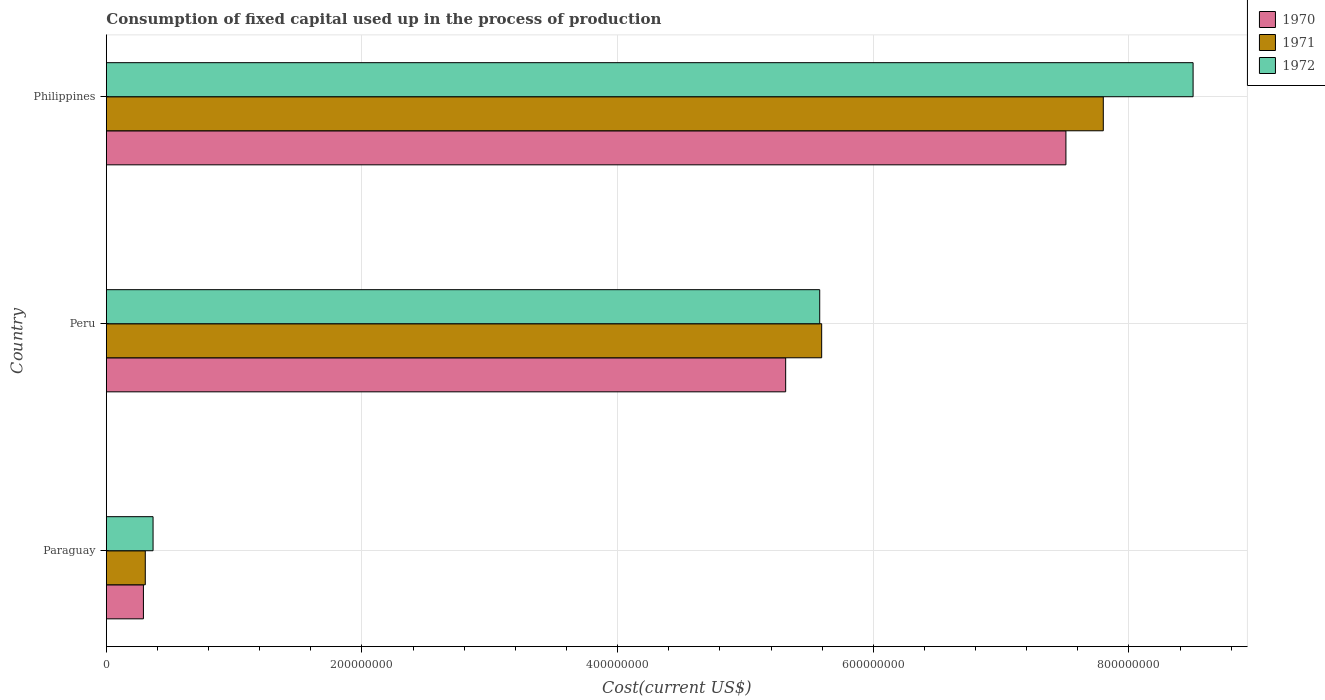How many different coloured bars are there?
Provide a succinct answer. 3. How many groups of bars are there?
Your answer should be very brief. 3. Are the number of bars on each tick of the Y-axis equal?
Your answer should be compact. Yes. How many bars are there on the 2nd tick from the top?
Give a very brief answer. 3. How many bars are there on the 3rd tick from the bottom?
Provide a short and direct response. 3. In how many cases, is the number of bars for a given country not equal to the number of legend labels?
Provide a succinct answer. 0. What is the amount consumed in the process of production in 1971 in Philippines?
Keep it short and to the point. 7.80e+08. Across all countries, what is the maximum amount consumed in the process of production in 1970?
Provide a short and direct response. 7.51e+08. Across all countries, what is the minimum amount consumed in the process of production in 1971?
Provide a succinct answer. 3.05e+07. In which country was the amount consumed in the process of production in 1970 maximum?
Give a very brief answer. Philippines. In which country was the amount consumed in the process of production in 1970 minimum?
Offer a very short reply. Paraguay. What is the total amount consumed in the process of production in 1970 in the graph?
Your answer should be compact. 1.31e+09. What is the difference between the amount consumed in the process of production in 1971 in Paraguay and that in Philippines?
Give a very brief answer. -7.50e+08. What is the difference between the amount consumed in the process of production in 1972 in Peru and the amount consumed in the process of production in 1970 in Paraguay?
Offer a terse response. 5.29e+08. What is the average amount consumed in the process of production in 1972 per country?
Your answer should be compact. 4.82e+08. What is the difference between the amount consumed in the process of production in 1972 and amount consumed in the process of production in 1971 in Peru?
Your response must be concise. -1.53e+06. In how many countries, is the amount consumed in the process of production in 1970 greater than 560000000 US$?
Your answer should be compact. 1. What is the ratio of the amount consumed in the process of production in 1971 in Paraguay to that in Peru?
Make the answer very short. 0.05. Is the amount consumed in the process of production in 1972 in Peru less than that in Philippines?
Your answer should be very brief. Yes. Is the difference between the amount consumed in the process of production in 1972 in Paraguay and Philippines greater than the difference between the amount consumed in the process of production in 1971 in Paraguay and Philippines?
Give a very brief answer. No. What is the difference between the highest and the second highest amount consumed in the process of production in 1970?
Keep it short and to the point. 2.19e+08. What is the difference between the highest and the lowest amount consumed in the process of production in 1972?
Offer a terse response. 8.14e+08. In how many countries, is the amount consumed in the process of production in 1971 greater than the average amount consumed in the process of production in 1971 taken over all countries?
Your answer should be very brief. 2. Is the sum of the amount consumed in the process of production in 1970 in Paraguay and Peru greater than the maximum amount consumed in the process of production in 1972 across all countries?
Give a very brief answer. No. Is it the case that in every country, the sum of the amount consumed in the process of production in 1971 and amount consumed in the process of production in 1972 is greater than the amount consumed in the process of production in 1970?
Offer a terse response. Yes. How many countries are there in the graph?
Offer a very short reply. 3. What is the difference between two consecutive major ticks on the X-axis?
Keep it short and to the point. 2.00e+08. Are the values on the major ticks of X-axis written in scientific E-notation?
Offer a very short reply. No. Does the graph contain any zero values?
Provide a short and direct response. No. What is the title of the graph?
Ensure brevity in your answer.  Consumption of fixed capital used up in the process of production. What is the label or title of the X-axis?
Provide a short and direct response. Cost(current US$). What is the label or title of the Y-axis?
Give a very brief answer. Country. What is the Cost(current US$) in 1970 in Paraguay?
Your answer should be compact. 2.90e+07. What is the Cost(current US$) of 1971 in Paraguay?
Your answer should be compact. 3.05e+07. What is the Cost(current US$) of 1972 in Paraguay?
Provide a short and direct response. 3.66e+07. What is the Cost(current US$) of 1970 in Peru?
Keep it short and to the point. 5.31e+08. What is the Cost(current US$) in 1971 in Peru?
Give a very brief answer. 5.60e+08. What is the Cost(current US$) in 1972 in Peru?
Make the answer very short. 5.58e+08. What is the Cost(current US$) of 1970 in Philippines?
Give a very brief answer. 7.51e+08. What is the Cost(current US$) of 1971 in Philippines?
Make the answer very short. 7.80e+08. What is the Cost(current US$) in 1972 in Philippines?
Ensure brevity in your answer.  8.50e+08. Across all countries, what is the maximum Cost(current US$) of 1970?
Keep it short and to the point. 7.51e+08. Across all countries, what is the maximum Cost(current US$) of 1971?
Your answer should be very brief. 7.80e+08. Across all countries, what is the maximum Cost(current US$) of 1972?
Give a very brief answer. 8.50e+08. Across all countries, what is the minimum Cost(current US$) in 1970?
Your response must be concise. 2.90e+07. Across all countries, what is the minimum Cost(current US$) in 1971?
Give a very brief answer. 3.05e+07. Across all countries, what is the minimum Cost(current US$) in 1972?
Your response must be concise. 3.66e+07. What is the total Cost(current US$) in 1970 in the graph?
Your response must be concise. 1.31e+09. What is the total Cost(current US$) in 1971 in the graph?
Keep it short and to the point. 1.37e+09. What is the total Cost(current US$) of 1972 in the graph?
Your answer should be compact. 1.44e+09. What is the difference between the Cost(current US$) of 1970 in Paraguay and that in Peru?
Keep it short and to the point. -5.02e+08. What is the difference between the Cost(current US$) in 1971 in Paraguay and that in Peru?
Your answer should be compact. -5.29e+08. What is the difference between the Cost(current US$) in 1972 in Paraguay and that in Peru?
Keep it short and to the point. -5.22e+08. What is the difference between the Cost(current US$) in 1970 in Paraguay and that in Philippines?
Make the answer very short. -7.22e+08. What is the difference between the Cost(current US$) of 1971 in Paraguay and that in Philippines?
Your answer should be very brief. -7.50e+08. What is the difference between the Cost(current US$) of 1972 in Paraguay and that in Philippines?
Keep it short and to the point. -8.14e+08. What is the difference between the Cost(current US$) of 1970 in Peru and that in Philippines?
Provide a short and direct response. -2.19e+08. What is the difference between the Cost(current US$) in 1971 in Peru and that in Philippines?
Offer a very short reply. -2.20e+08. What is the difference between the Cost(current US$) in 1972 in Peru and that in Philippines?
Your answer should be very brief. -2.92e+08. What is the difference between the Cost(current US$) of 1970 in Paraguay and the Cost(current US$) of 1971 in Peru?
Offer a terse response. -5.31e+08. What is the difference between the Cost(current US$) of 1970 in Paraguay and the Cost(current US$) of 1972 in Peru?
Keep it short and to the point. -5.29e+08. What is the difference between the Cost(current US$) in 1971 in Paraguay and the Cost(current US$) in 1972 in Peru?
Your response must be concise. -5.28e+08. What is the difference between the Cost(current US$) in 1970 in Paraguay and the Cost(current US$) in 1971 in Philippines?
Provide a succinct answer. -7.51e+08. What is the difference between the Cost(current US$) of 1970 in Paraguay and the Cost(current US$) of 1972 in Philippines?
Offer a very short reply. -8.21e+08. What is the difference between the Cost(current US$) in 1971 in Paraguay and the Cost(current US$) in 1972 in Philippines?
Provide a succinct answer. -8.20e+08. What is the difference between the Cost(current US$) of 1970 in Peru and the Cost(current US$) of 1971 in Philippines?
Your answer should be very brief. -2.48e+08. What is the difference between the Cost(current US$) of 1970 in Peru and the Cost(current US$) of 1972 in Philippines?
Keep it short and to the point. -3.19e+08. What is the difference between the Cost(current US$) of 1971 in Peru and the Cost(current US$) of 1972 in Philippines?
Keep it short and to the point. -2.91e+08. What is the average Cost(current US$) in 1970 per country?
Offer a terse response. 4.37e+08. What is the average Cost(current US$) of 1971 per country?
Your response must be concise. 4.57e+08. What is the average Cost(current US$) of 1972 per country?
Your response must be concise. 4.82e+08. What is the difference between the Cost(current US$) in 1970 and Cost(current US$) in 1971 in Paraguay?
Your answer should be very brief. -1.46e+06. What is the difference between the Cost(current US$) of 1970 and Cost(current US$) of 1972 in Paraguay?
Offer a terse response. -7.54e+06. What is the difference between the Cost(current US$) in 1971 and Cost(current US$) in 1972 in Paraguay?
Your answer should be very brief. -6.08e+06. What is the difference between the Cost(current US$) of 1970 and Cost(current US$) of 1971 in Peru?
Your response must be concise. -2.82e+07. What is the difference between the Cost(current US$) of 1970 and Cost(current US$) of 1972 in Peru?
Provide a succinct answer. -2.66e+07. What is the difference between the Cost(current US$) of 1971 and Cost(current US$) of 1972 in Peru?
Your response must be concise. 1.53e+06. What is the difference between the Cost(current US$) in 1970 and Cost(current US$) in 1971 in Philippines?
Offer a terse response. -2.92e+07. What is the difference between the Cost(current US$) in 1970 and Cost(current US$) in 1972 in Philippines?
Provide a short and direct response. -9.95e+07. What is the difference between the Cost(current US$) of 1971 and Cost(current US$) of 1972 in Philippines?
Provide a succinct answer. -7.02e+07. What is the ratio of the Cost(current US$) of 1970 in Paraguay to that in Peru?
Offer a very short reply. 0.05. What is the ratio of the Cost(current US$) of 1971 in Paraguay to that in Peru?
Your response must be concise. 0.05. What is the ratio of the Cost(current US$) of 1972 in Paraguay to that in Peru?
Make the answer very short. 0.07. What is the ratio of the Cost(current US$) of 1970 in Paraguay to that in Philippines?
Offer a very short reply. 0.04. What is the ratio of the Cost(current US$) of 1971 in Paraguay to that in Philippines?
Offer a very short reply. 0.04. What is the ratio of the Cost(current US$) of 1972 in Paraguay to that in Philippines?
Offer a terse response. 0.04. What is the ratio of the Cost(current US$) in 1970 in Peru to that in Philippines?
Your answer should be compact. 0.71. What is the ratio of the Cost(current US$) of 1971 in Peru to that in Philippines?
Ensure brevity in your answer.  0.72. What is the ratio of the Cost(current US$) of 1972 in Peru to that in Philippines?
Make the answer very short. 0.66. What is the difference between the highest and the second highest Cost(current US$) in 1970?
Make the answer very short. 2.19e+08. What is the difference between the highest and the second highest Cost(current US$) of 1971?
Provide a succinct answer. 2.20e+08. What is the difference between the highest and the second highest Cost(current US$) in 1972?
Ensure brevity in your answer.  2.92e+08. What is the difference between the highest and the lowest Cost(current US$) in 1970?
Your answer should be compact. 7.22e+08. What is the difference between the highest and the lowest Cost(current US$) in 1971?
Provide a succinct answer. 7.50e+08. What is the difference between the highest and the lowest Cost(current US$) of 1972?
Offer a terse response. 8.14e+08. 